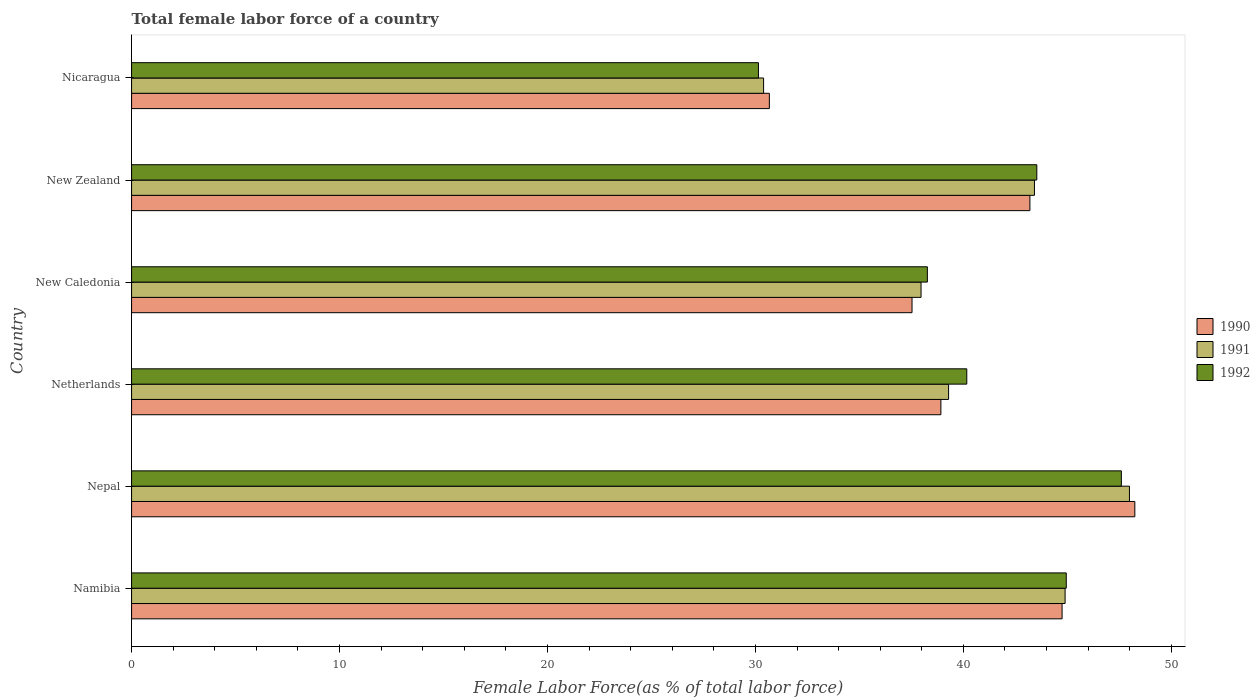How many groups of bars are there?
Make the answer very short. 6. Are the number of bars per tick equal to the number of legend labels?
Your answer should be very brief. Yes. How many bars are there on the 4th tick from the top?
Ensure brevity in your answer.  3. How many bars are there on the 4th tick from the bottom?
Your answer should be very brief. 3. What is the label of the 6th group of bars from the top?
Keep it short and to the point. Namibia. In how many cases, is the number of bars for a given country not equal to the number of legend labels?
Provide a succinct answer. 0. What is the percentage of female labor force in 1992 in New Zealand?
Your answer should be very brief. 43.53. Across all countries, what is the maximum percentage of female labor force in 1991?
Your response must be concise. 47.99. Across all countries, what is the minimum percentage of female labor force in 1991?
Provide a succinct answer. 30.39. In which country was the percentage of female labor force in 1991 maximum?
Keep it short and to the point. Nepal. In which country was the percentage of female labor force in 1992 minimum?
Keep it short and to the point. Nicaragua. What is the total percentage of female labor force in 1990 in the graph?
Offer a very short reply. 243.3. What is the difference between the percentage of female labor force in 1990 in Nepal and that in New Zealand?
Offer a very short reply. 5.05. What is the difference between the percentage of female labor force in 1991 in New Zealand and the percentage of female labor force in 1992 in Nepal?
Provide a short and direct response. -4.18. What is the average percentage of female labor force in 1992 per country?
Offer a terse response. 40.77. What is the difference between the percentage of female labor force in 1992 and percentage of female labor force in 1991 in New Caledonia?
Offer a very short reply. 0.3. What is the ratio of the percentage of female labor force in 1992 in Nepal to that in Netherlands?
Provide a succinct answer. 1.19. Is the percentage of female labor force in 1991 in Namibia less than that in Nepal?
Give a very brief answer. Yes. What is the difference between the highest and the second highest percentage of female labor force in 1991?
Offer a very short reply. 3.09. What is the difference between the highest and the lowest percentage of female labor force in 1992?
Make the answer very short. 17.45. In how many countries, is the percentage of female labor force in 1990 greater than the average percentage of female labor force in 1990 taken over all countries?
Give a very brief answer. 3. What does the 1st bar from the bottom in Nicaragua represents?
Keep it short and to the point. 1990. How many bars are there?
Your response must be concise. 18. Are all the bars in the graph horizontal?
Offer a terse response. Yes. Does the graph contain any zero values?
Ensure brevity in your answer.  No. Does the graph contain grids?
Offer a terse response. No. How many legend labels are there?
Ensure brevity in your answer.  3. What is the title of the graph?
Your response must be concise. Total female labor force of a country. What is the label or title of the X-axis?
Provide a succinct answer. Female Labor Force(as % of total labor force). What is the label or title of the Y-axis?
Your response must be concise. Country. What is the Female Labor Force(as % of total labor force) in 1990 in Namibia?
Your answer should be very brief. 44.75. What is the Female Labor Force(as % of total labor force) of 1991 in Namibia?
Offer a very short reply. 44.89. What is the Female Labor Force(as % of total labor force) in 1992 in Namibia?
Provide a succinct answer. 44.95. What is the Female Labor Force(as % of total labor force) of 1990 in Nepal?
Provide a succinct answer. 48.24. What is the Female Labor Force(as % of total labor force) in 1991 in Nepal?
Give a very brief answer. 47.99. What is the Female Labor Force(as % of total labor force) of 1992 in Nepal?
Offer a terse response. 47.6. What is the Female Labor Force(as % of total labor force) in 1990 in Netherlands?
Your response must be concise. 38.92. What is the Female Labor Force(as % of total labor force) in 1991 in Netherlands?
Your answer should be compact. 39.29. What is the Female Labor Force(as % of total labor force) of 1992 in Netherlands?
Provide a succinct answer. 40.16. What is the Female Labor Force(as % of total labor force) in 1990 in New Caledonia?
Keep it short and to the point. 37.53. What is the Female Labor Force(as % of total labor force) of 1991 in New Caledonia?
Make the answer very short. 37.96. What is the Female Labor Force(as % of total labor force) of 1992 in New Caledonia?
Provide a succinct answer. 38.27. What is the Female Labor Force(as % of total labor force) in 1990 in New Zealand?
Provide a succinct answer. 43.2. What is the Female Labor Force(as % of total labor force) of 1991 in New Zealand?
Offer a very short reply. 43.42. What is the Female Labor Force(as % of total labor force) in 1992 in New Zealand?
Keep it short and to the point. 43.53. What is the Female Labor Force(as % of total labor force) in 1990 in Nicaragua?
Offer a terse response. 30.67. What is the Female Labor Force(as % of total labor force) of 1991 in Nicaragua?
Give a very brief answer. 30.39. What is the Female Labor Force(as % of total labor force) in 1992 in Nicaragua?
Your response must be concise. 30.14. Across all countries, what is the maximum Female Labor Force(as % of total labor force) in 1990?
Your answer should be very brief. 48.24. Across all countries, what is the maximum Female Labor Force(as % of total labor force) of 1991?
Ensure brevity in your answer.  47.99. Across all countries, what is the maximum Female Labor Force(as % of total labor force) in 1992?
Your answer should be compact. 47.6. Across all countries, what is the minimum Female Labor Force(as % of total labor force) in 1990?
Keep it short and to the point. 30.67. Across all countries, what is the minimum Female Labor Force(as % of total labor force) of 1991?
Provide a short and direct response. 30.39. Across all countries, what is the minimum Female Labor Force(as % of total labor force) in 1992?
Offer a very short reply. 30.14. What is the total Female Labor Force(as % of total labor force) in 1990 in the graph?
Provide a short and direct response. 243.3. What is the total Female Labor Force(as % of total labor force) of 1991 in the graph?
Provide a short and direct response. 243.94. What is the total Female Labor Force(as % of total labor force) in 1992 in the graph?
Offer a very short reply. 244.65. What is the difference between the Female Labor Force(as % of total labor force) of 1990 in Namibia and that in Nepal?
Your answer should be very brief. -3.5. What is the difference between the Female Labor Force(as % of total labor force) in 1991 in Namibia and that in Nepal?
Offer a very short reply. -3.09. What is the difference between the Female Labor Force(as % of total labor force) in 1992 in Namibia and that in Nepal?
Give a very brief answer. -2.65. What is the difference between the Female Labor Force(as % of total labor force) of 1990 in Namibia and that in Netherlands?
Provide a succinct answer. 5.83. What is the difference between the Female Labor Force(as % of total labor force) of 1991 in Namibia and that in Netherlands?
Your response must be concise. 5.6. What is the difference between the Female Labor Force(as % of total labor force) of 1992 in Namibia and that in Netherlands?
Ensure brevity in your answer.  4.78. What is the difference between the Female Labor Force(as % of total labor force) of 1990 in Namibia and that in New Caledonia?
Give a very brief answer. 7.22. What is the difference between the Female Labor Force(as % of total labor force) of 1991 in Namibia and that in New Caledonia?
Your answer should be compact. 6.93. What is the difference between the Female Labor Force(as % of total labor force) of 1992 in Namibia and that in New Caledonia?
Ensure brevity in your answer.  6.68. What is the difference between the Female Labor Force(as % of total labor force) in 1990 in Namibia and that in New Zealand?
Your answer should be compact. 1.55. What is the difference between the Female Labor Force(as % of total labor force) in 1991 in Namibia and that in New Zealand?
Ensure brevity in your answer.  1.47. What is the difference between the Female Labor Force(as % of total labor force) in 1992 in Namibia and that in New Zealand?
Make the answer very short. 1.42. What is the difference between the Female Labor Force(as % of total labor force) in 1990 in Namibia and that in Nicaragua?
Give a very brief answer. 14.08. What is the difference between the Female Labor Force(as % of total labor force) of 1991 in Namibia and that in Nicaragua?
Ensure brevity in your answer.  14.5. What is the difference between the Female Labor Force(as % of total labor force) in 1992 in Namibia and that in Nicaragua?
Your answer should be compact. 14.8. What is the difference between the Female Labor Force(as % of total labor force) of 1990 in Nepal and that in Netherlands?
Make the answer very short. 9.33. What is the difference between the Female Labor Force(as % of total labor force) of 1991 in Nepal and that in Netherlands?
Your answer should be very brief. 8.7. What is the difference between the Female Labor Force(as % of total labor force) of 1992 in Nepal and that in Netherlands?
Give a very brief answer. 7.43. What is the difference between the Female Labor Force(as % of total labor force) in 1990 in Nepal and that in New Caledonia?
Keep it short and to the point. 10.71. What is the difference between the Female Labor Force(as % of total labor force) of 1991 in Nepal and that in New Caledonia?
Your response must be concise. 10.02. What is the difference between the Female Labor Force(as % of total labor force) in 1992 in Nepal and that in New Caledonia?
Offer a very short reply. 9.33. What is the difference between the Female Labor Force(as % of total labor force) of 1990 in Nepal and that in New Zealand?
Offer a terse response. 5.05. What is the difference between the Female Labor Force(as % of total labor force) in 1991 in Nepal and that in New Zealand?
Offer a very short reply. 4.57. What is the difference between the Female Labor Force(as % of total labor force) in 1992 in Nepal and that in New Zealand?
Offer a very short reply. 4.07. What is the difference between the Female Labor Force(as % of total labor force) in 1990 in Nepal and that in Nicaragua?
Make the answer very short. 17.58. What is the difference between the Female Labor Force(as % of total labor force) of 1991 in Nepal and that in Nicaragua?
Give a very brief answer. 17.59. What is the difference between the Female Labor Force(as % of total labor force) of 1992 in Nepal and that in Nicaragua?
Keep it short and to the point. 17.45. What is the difference between the Female Labor Force(as % of total labor force) in 1990 in Netherlands and that in New Caledonia?
Provide a short and direct response. 1.39. What is the difference between the Female Labor Force(as % of total labor force) in 1991 in Netherlands and that in New Caledonia?
Your answer should be very brief. 1.32. What is the difference between the Female Labor Force(as % of total labor force) of 1992 in Netherlands and that in New Caledonia?
Provide a short and direct response. 1.9. What is the difference between the Female Labor Force(as % of total labor force) in 1990 in Netherlands and that in New Zealand?
Your answer should be compact. -4.28. What is the difference between the Female Labor Force(as % of total labor force) in 1991 in Netherlands and that in New Zealand?
Make the answer very short. -4.13. What is the difference between the Female Labor Force(as % of total labor force) of 1992 in Netherlands and that in New Zealand?
Your answer should be very brief. -3.37. What is the difference between the Female Labor Force(as % of total labor force) of 1990 in Netherlands and that in Nicaragua?
Give a very brief answer. 8.25. What is the difference between the Female Labor Force(as % of total labor force) in 1991 in Netherlands and that in Nicaragua?
Your answer should be compact. 8.9. What is the difference between the Female Labor Force(as % of total labor force) of 1992 in Netherlands and that in Nicaragua?
Keep it short and to the point. 10.02. What is the difference between the Female Labor Force(as % of total labor force) of 1990 in New Caledonia and that in New Zealand?
Ensure brevity in your answer.  -5.67. What is the difference between the Female Labor Force(as % of total labor force) of 1991 in New Caledonia and that in New Zealand?
Offer a very short reply. -5.45. What is the difference between the Female Labor Force(as % of total labor force) of 1992 in New Caledonia and that in New Zealand?
Give a very brief answer. -5.26. What is the difference between the Female Labor Force(as % of total labor force) of 1990 in New Caledonia and that in Nicaragua?
Provide a succinct answer. 6.86. What is the difference between the Female Labor Force(as % of total labor force) in 1991 in New Caledonia and that in Nicaragua?
Your answer should be compact. 7.57. What is the difference between the Female Labor Force(as % of total labor force) in 1992 in New Caledonia and that in Nicaragua?
Your answer should be compact. 8.12. What is the difference between the Female Labor Force(as % of total labor force) in 1990 in New Zealand and that in Nicaragua?
Your answer should be compact. 12.53. What is the difference between the Female Labor Force(as % of total labor force) of 1991 in New Zealand and that in Nicaragua?
Keep it short and to the point. 13.03. What is the difference between the Female Labor Force(as % of total labor force) in 1992 in New Zealand and that in Nicaragua?
Your response must be concise. 13.39. What is the difference between the Female Labor Force(as % of total labor force) in 1990 in Namibia and the Female Labor Force(as % of total labor force) in 1991 in Nepal?
Your answer should be very brief. -3.24. What is the difference between the Female Labor Force(as % of total labor force) in 1990 in Namibia and the Female Labor Force(as % of total labor force) in 1992 in Nepal?
Keep it short and to the point. -2.85. What is the difference between the Female Labor Force(as % of total labor force) of 1991 in Namibia and the Female Labor Force(as % of total labor force) of 1992 in Nepal?
Give a very brief answer. -2.71. What is the difference between the Female Labor Force(as % of total labor force) of 1990 in Namibia and the Female Labor Force(as % of total labor force) of 1991 in Netherlands?
Your answer should be very brief. 5.46. What is the difference between the Female Labor Force(as % of total labor force) of 1990 in Namibia and the Female Labor Force(as % of total labor force) of 1992 in Netherlands?
Offer a very short reply. 4.58. What is the difference between the Female Labor Force(as % of total labor force) in 1991 in Namibia and the Female Labor Force(as % of total labor force) in 1992 in Netherlands?
Make the answer very short. 4.73. What is the difference between the Female Labor Force(as % of total labor force) of 1990 in Namibia and the Female Labor Force(as % of total labor force) of 1991 in New Caledonia?
Offer a terse response. 6.78. What is the difference between the Female Labor Force(as % of total labor force) in 1990 in Namibia and the Female Labor Force(as % of total labor force) in 1992 in New Caledonia?
Your answer should be very brief. 6.48. What is the difference between the Female Labor Force(as % of total labor force) of 1991 in Namibia and the Female Labor Force(as % of total labor force) of 1992 in New Caledonia?
Make the answer very short. 6.62. What is the difference between the Female Labor Force(as % of total labor force) in 1990 in Namibia and the Female Labor Force(as % of total labor force) in 1991 in New Zealand?
Give a very brief answer. 1.33. What is the difference between the Female Labor Force(as % of total labor force) of 1990 in Namibia and the Female Labor Force(as % of total labor force) of 1992 in New Zealand?
Offer a very short reply. 1.22. What is the difference between the Female Labor Force(as % of total labor force) in 1991 in Namibia and the Female Labor Force(as % of total labor force) in 1992 in New Zealand?
Offer a very short reply. 1.36. What is the difference between the Female Labor Force(as % of total labor force) in 1990 in Namibia and the Female Labor Force(as % of total labor force) in 1991 in Nicaragua?
Your answer should be very brief. 14.35. What is the difference between the Female Labor Force(as % of total labor force) in 1990 in Namibia and the Female Labor Force(as % of total labor force) in 1992 in Nicaragua?
Provide a short and direct response. 14.6. What is the difference between the Female Labor Force(as % of total labor force) of 1991 in Namibia and the Female Labor Force(as % of total labor force) of 1992 in Nicaragua?
Provide a short and direct response. 14.75. What is the difference between the Female Labor Force(as % of total labor force) of 1990 in Nepal and the Female Labor Force(as % of total labor force) of 1991 in Netherlands?
Make the answer very short. 8.96. What is the difference between the Female Labor Force(as % of total labor force) in 1990 in Nepal and the Female Labor Force(as % of total labor force) in 1992 in Netherlands?
Your answer should be very brief. 8.08. What is the difference between the Female Labor Force(as % of total labor force) of 1991 in Nepal and the Female Labor Force(as % of total labor force) of 1992 in Netherlands?
Provide a succinct answer. 7.82. What is the difference between the Female Labor Force(as % of total labor force) in 1990 in Nepal and the Female Labor Force(as % of total labor force) in 1991 in New Caledonia?
Give a very brief answer. 10.28. What is the difference between the Female Labor Force(as % of total labor force) of 1990 in Nepal and the Female Labor Force(as % of total labor force) of 1992 in New Caledonia?
Keep it short and to the point. 9.98. What is the difference between the Female Labor Force(as % of total labor force) of 1991 in Nepal and the Female Labor Force(as % of total labor force) of 1992 in New Caledonia?
Your answer should be compact. 9.72. What is the difference between the Female Labor Force(as % of total labor force) in 1990 in Nepal and the Female Labor Force(as % of total labor force) in 1991 in New Zealand?
Offer a very short reply. 4.83. What is the difference between the Female Labor Force(as % of total labor force) of 1990 in Nepal and the Female Labor Force(as % of total labor force) of 1992 in New Zealand?
Ensure brevity in your answer.  4.71. What is the difference between the Female Labor Force(as % of total labor force) of 1991 in Nepal and the Female Labor Force(as % of total labor force) of 1992 in New Zealand?
Keep it short and to the point. 4.46. What is the difference between the Female Labor Force(as % of total labor force) of 1990 in Nepal and the Female Labor Force(as % of total labor force) of 1991 in Nicaragua?
Offer a terse response. 17.85. What is the difference between the Female Labor Force(as % of total labor force) in 1990 in Nepal and the Female Labor Force(as % of total labor force) in 1992 in Nicaragua?
Give a very brief answer. 18.1. What is the difference between the Female Labor Force(as % of total labor force) in 1991 in Nepal and the Female Labor Force(as % of total labor force) in 1992 in Nicaragua?
Offer a terse response. 17.84. What is the difference between the Female Labor Force(as % of total labor force) of 1990 in Netherlands and the Female Labor Force(as % of total labor force) of 1991 in New Caledonia?
Provide a succinct answer. 0.95. What is the difference between the Female Labor Force(as % of total labor force) in 1990 in Netherlands and the Female Labor Force(as % of total labor force) in 1992 in New Caledonia?
Your answer should be compact. 0.65. What is the difference between the Female Labor Force(as % of total labor force) in 1991 in Netherlands and the Female Labor Force(as % of total labor force) in 1992 in New Caledonia?
Provide a short and direct response. 1.02. What is the difference between the Female Labor Force(as % of total labor force) in 1990 in Netherlands and the Female Labor Force(as % of total labor force) in 1991 in New Zealand?
Offer a terse response. -4.5. What is the difference between the Female Labor Force(as % of total labor force) in 1990 in Netherlands and the Female Labor Force(as % of total labor force) in 1992 in New Zealand?
Provide a short and direct response. -4.61. What is the difference between the Female Labor Force(as % of total labor force) of 1991 in Netherlands and the Female Labor Force(as % of total labor force) of 1992 in New Zealand?
Your response must be concise. -4.24. What is the difference between the Female Labor Force(as % of total labor force) of 1990 in Netherlands and the Female Labor Force(as % of total labor force) of 1991 in Nicaragua?
Make the answer very short. 8.53. What is the difference between the Female Labor Force(as % of total labor force) in 1990 in Netherlands and the Female Labor Force(as % of total labor force) in 1992 in Nicaragua?
Your answer should be compact. 8.77. What is the difference between the Female Labor Force(as % of total labor force) of 1991 in Netherlands and the Female Labor Force(as % of total labor force) of 1992 in Nicaragua?
Give a very brief answer. 9.14. What is the difference between the Female Labor Force(as % of total labor force) in 1990 in New Caledonia and the Female Labor Force(as % of total labor force) in 1991 in New Zealand?
Your answer should be very brief. -5.89. What is the difference between the Female Labor Force(as % of total labor force) of 1990 in New Caledonia and the Female Labor Force(as % of total labor force) of 1992 in New Zealand?
Make the answer very short. -6. What is the difference between the Female Labor Force(as % of total labor force) of 1991 in New Caledonia and the Female Labor Force(as % of total labor force) of 1992 in New Zealand?
Your answer should be very brief. -5.57. What is the difference between the Female Labor Force(as % of total labor force) of 1990 in New Caledonia and the Female Labor Force(as % of total labor force) of 1991 in Nicaragua?
Provide a succinct answer. 7.14. What is the difference between the Female Labor Force(as % of total labor force) of 1990 in New Caledonia and the Female Labor Force(as % of total labor force) of 1992 in Nicaragua?
Your response must be concise. 7.39. What is the difference between the Female Labor Force(as % of total labor force) in 1991 in New Caledonia and the Female Labor Force(as % of total labor force) in 1992 in Nicaragua?
Make the answer very short. 7.82. What is the difference between the Female Labor Force(as % of total labor force) of 1990 in New Zealand and the Female Labor Force(as % of total labor force) of 1991 in Nicaragua?
Provide a short and direct response. 12.81. What is the difference between the Female Labor Force(as % of total labor force) of 1990 in New Zealand and the Female Labor Force(as % of total labor force) of 1992 in Nicaragua?
Provide a succinct answer. 13.05. What is the difference between the Female Labor Force(as % of total labor force) of 1991 in New Zealand and the Female Labor Force(as % of total labor force) of 1992 in Nicaragua?
Make the answer very short. 13.27. What is the average Female Labor Force(as % of total labor force) in 1990 per country?
Offer a very short reply. 40.55. What is the average Female Labor Force(as % of total labor force) in 1991 per country?
Provide a succinct answer. 40.66. What is the average Female Labor Force(as % of total labor force) of 1992 per country?
Give a very brief answer. 40.77. What is the difference between the Female Labor Force(as % of total labor force) of 1990 and Female Labor Force(as % of total labor force) of 1991 in Namibia?
Your response must be concise. -0.15. What is the difference between the Female Labor Force(as % of total labor force) of 1990 and Female Labor Force(as % of total labor force) of 1992 in Namibia?
Provide a short and direct response. -0.2. What is the difference between the Female Labor Force(as % of total labor force) of 1991 and Female Labor Force(as % of total labor force) of 1992 in Namibia?
Your response must be concise. -0.06. What is the difference between the Female Labor Force(as % of total labor force) in 1990 and Female Labor Force(as % of total labor force) in 1991 in Nepal?
Offer a very short reply. 0.26. What is the difference between the Female Labor Force(as % of total labor force) in 1990 and Female Labor Force(as % of total labor force) in 1992 in Nepal?
Your answer should be very brief. 0.65. What is the difference between the Female Labor Force(as % of total labor force) in 1991 and Female Labor Force(as % of total labor force) in 1992 in Nepal?
Offer a terse response. 0.39. What is the difference between the Female Labor Force(as % of total labor force) in 1990 and Female Labor Force(as % of total labor force) in 1991 in Netherlands?
Make the answer very short. -0.37. What is the difference between the Female Labor Force(as % of total labor force) of 1990 and Female Labor Force(as % of total labor force) of 1992 in Netherlands?
Provide a short and direct response. -1.25. What is the difference between the Female Labor Force(as % of total labor force) in 1991 and Female Labor Force(as % of total labor force) in 1992 in Netherlands?
Keep it short and to the point. -0.88. What is the difference between the Female Labor Force(as % of total labor force) of 1990 and Female Labor Force(as % of total labor force) of 1991 in New Caledonia?
Provide a short and direct response. -0.43. What is the difference between the Female Labor Force(as % of total labor force) of 1990 and Female Labor Force(as % of total labor force) of 1992 in New Caledonia?
Keep it short and to the point. -0.74. What is the difference between the Female Labor Force(as % of total labor force) of 1991 and Female Labor Force(as % of total labor force) of 1992 in New Caledonia?
Keep it short and to the point. -0.3. What is the difference between the Female Labor Force(as % of total labor force) of 1990 and Female Labor Force(as % of total labor force) of 1991 in New Zealand?
Give a very brief answer. -0.22. What is the difference between the Female Labor Force(as % of total labor force) in 1990 and Female Labor Force(as % of total labor force) in 1992 in New Zealand?
Ensure brevity in your answer.  -0.33. What is the difference between the Female Labor Force(as % of total labor force) in 1991 and Female Labor Force(as % of total labor force) in 1992 in New Zealand?
Provide a succinct answer. -0.11. What is the difference between the Female Labor Force(as % of total labor force) in 1990 and Female Labor Force(as % of total labor force) in 1991 in Nicaragua?
Offer a very short reply. 0.28. What is the difference between the Female Labor Force(as % of total labor force) in 1990 and Female Labor Force(as % of total labor force) in 1992 in Nicaragua?
Keep it short and to the point. 0.53. What is the difference between the Female Labor Force(as % of total labor force) of 1991 and Female Labor Force(as % of total labor force) of 1992 in Nicaragua?
Your response must be concise. 0.25. What is the ratio of the Female Labor Force(as % of total labor force) of 1990 in Namibia to that in Nepal?
Provide a short and direct response. 0.93. What is the ratio of the Female Labor Force(as % of total labor force) in 1991 in Namibia to that in Nepal?
Give a very brief answer. 0.94. What is the ratio of the Female Labor Force(as % of total labor force) in 1992 in Namibia to that in Nepal?
Your answer should be compact. 0.94. What is the ratio of the Female Labor Force(as % of total labor force) of 1990 in Namibia to that in Netherlands?
Provide a short and direct response. 1.15. What is the ratio of the Female Labor Force(as % of total labor force) of 1991 in Namibia to that in Netherlands?
Offer a terse response. 1.14. What is the ratio of the Female Labor Force(as % of total labor force) of 1992 in Namibia to that in Netherlands?
Provide a short and direct response. 1.12. What is the ratio of the Female Labor Force(as % of total labor force) of 1990 in Namibia to that in New Caledonia?
Your answer should be very brief. 1.19. What is the ratio of the Female Labor Force(as % of total labor force) in 1991 in Namibia to that in New Caledonia?
Your answer should be very brief. 1.18. What is the ratio of the Female Labor Force(as % of total labor force) in 1992 in Namibia to that in New Caledonia?
Make the answer very short. 1.17. What is the ratio of the Female Labor Force(as % of total labor force) of 1990 in Namibia to that in New Zealand?
Provide a short and direct response. 1.04. What is the ratio of the Female Labor Force(as % of total labor force) of 1991 in Namibia to that in New Zealand?
Provide a succinct answer. 1.03. What is the ratio of the Female Labor Force(as % of total labor force) in 1992 in Namibia to that in New Zealand?
Your answer should be very brief. 1.03. What is the ratio of the Female Labor Force(as % of total labor force) of 1990 in Namibia to that in Nicaragua?
Provide a succinct answer. 1.46. What is the ratio of the Female Labor Force(as % of total labor force) in 1991 in Namibia to that in Nicaragua?
Make the answer very short. 1.48. What is the ratio of the Female Labor Force(as % of total labor force) in 1992 in Namibia to that in Nicaragua?
Provide a succinct answer. 1.49. What is the ratio of the Female Labor Force(as % of total labor force) of 1990 in Nepal to that in Netherlands?
Provide a short and direct response. 1.24. What is the ratio of the Female Labor Force(as % of total labor force) in 1991 in Nepal to that in Netherlands?
Give a very brief answer. 1.22. What is the ratio of the Female Labor Force(as % of total labor force) in 1992 in Nepal to that in Netherlands?
Offer a very short reply. 1.19. What is the ratio of the Female Labor Force(as % of total labor force) in 1990 in Nepal to that in New Caledonia?
Your answer should be compact. 1.29. What is the ratio of the Female Labor Force(as % of total labor force) in 1991 in Nepal to that in New Caledonia?
Offer a very short reply. 1.26. What is the ratio of the Female Labor Force(as % of total labor force) of 1992 in Nepal to that in New Caledonia?
Offer a very short reply. 1.24. What is the ratio of the Female Labor Force(as % of total labor force) of 1990 in Nepal to that in New Zealand?
Provide a short and direct response. 1.12. What is the ratio of the Female Labor Force(as % of total labor force) of 1991 in Nepal to that in New Zealand?
Your answer should be very brief. 1.11. What is the ratio of the Female Labor Force(as % of total labor force) of 1992 in Nepal to that in New Zealand?
Provide a succinct answer. 1.09. What is the ratio of the Female Labor Force(as % of total labor force) in 1990 in Nepal to that in Nicaragua?
Keep it short and to the point. 1.57. What is the ratio of the Female Labor Force(as % of total labor force) in 1991 in Nepal to that in Nicaragua?
Make the answer very short. 1.58. What is the ratio of the Female Labor Force(as % of total labor force) of 1992 in Nepal to that in Nicaragua?
Your response must be concise. 1.58. What is the ratio of the Female Labor Force(as % of total labor force) of 1991 in Netherlands to that in New Caledonia?
Ensure brevity in your answer.  1.03. What is the ratio of the Female Labor Force(as % of total labor force) in 1992 in Netherlands to that in New Caledonia?
Your answer should be very brief. 1.05. What is the ratio of the Female Labor Force(as % of total labor force) in 1990 in Netherlands to that in New Zealand?
Give a very brief answer. 0.9. What is the ratio of the Female Labor Force(as % of total labor force) of 1991 in Netherlands to that in New Zealand?
Your response must be concise. 0.9. What is the ratio of the Female Labor Force(as % of total labor force) of 1992 in Netherlands to that in New Zealand?
Make the answer very short. 0.92. What is the ratio of the Female Labor Force(as % of total labor force) of 1990 in Netherlands to that in Nicaragua?
Provide a succinct answer. 1.27. What is the ratio of the Female Labor Force(as % of total labor force) in 1991 in Netherlands to that in Nicaragua?
Provide a short and direct response. 1.29. What is the ratio of the Female Labor Force(as % of total labor force) in 1992 in Netherlands to that in Nicaragua?
Offer a very short reply. 1.33. What is the ratio of the Female Labor Force(as % of total labor force) in 1990 in New Caledonia to that in New Zealand?
Provide a succinct answer. 0.87. What is the ratio of the Female Labor Force(as % of total labor force) in 1991 in New Caledonia to that in New Zealand?
Make the answer very short. 0.87. What is the ratio of the Female Labor Force(as % of total labor force) in 1992 in New Caledonia to that in New Zealand?
Ensure brevity in your answer.  0.88. What is the ratio of the Female Labor Force(as % of total labor force) of 1990 in New Caledonia to that in Nicaragua?
Offer a terse response. 1.22. What is the ratio of the Female Labor Force(as % of total labor force) of 1991 in New Caledonia to that in Nicaragua?
Give a very brief answer. 1.25. What is the ratio of the Female Labor Force(as % of total labor force) of 1992 in New Caledonia to that in Nicaragua?
Provide a short and direct response. 1.27. What is the ratio of the Female Labor Force(as % of total labor force) in 1990 in New Zealand to that in Nicaragua?
Give a very brief answer. 1.41. What is the ratio of the Female Labor Force(as % of total labor force) of 1991 in New Zealand to that in Nicaragua?
Offer a very short reply. 1.43. What is the ratio of the Female Labor Force(as % of total labor force) in 1992 in New Zealand to that in Nicaragua?
Your response must be concise. 1.44. What is the difference between the highest and the second highest Female Labor Force(as % of total labor force) in 1990?
Offer a terse response. 3.5. What is the difference between the highest and the second highest Female Labor Force(as % of total labor force) in 1991?
Make the answer very short. 3.09. What is the difference between the highest and the second highest Female Labor Force(as % of total labor force) in 1992?
Your response must be concise. 2.65. What is the difference between the highest and the lowest Female Labor Force(as % of total labor force) of 1990?
Give a very brief answer. 17.58. What is the difference between the highest and the lowest Female Labor Force(as % of total labor force) in 1991?
Ensure brevity in your answer.  17.59. What is the difference between the highest and the lowest Female Labor Force(as % of total labor force) in 1992?
Give a very brief answer. 17.45. 